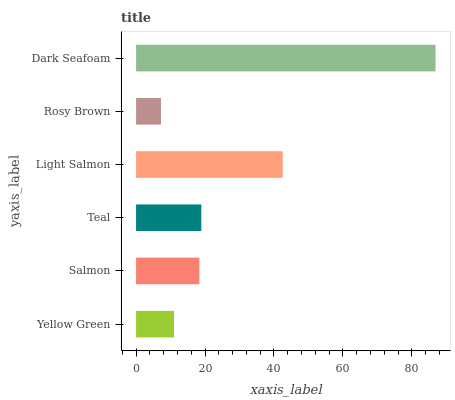Is Rosy Brown the minimum?
Answer yes or no. Yes. Is Dark Seafoam the maximum?
Answer yes or no. Yes. Is Salmon the minimum?
Answer yes or no. No. Is Salmon the maximum?
Answer yes or no. No. Is Salmon greater than Yellow Green?
Answer yes or no. Yes. Is Yellow Green less than Salmon?
Answer yes or no. Yes. Is Yellow Green greater than Salmon?
Answer yes or no. No. Is Salmon less than Yellow Green?
Answer yes or no. No. Is Teal the high median?
Answer yes or no. Yes. Is Salmon the low median?
Answer yes or no. Yes. Is Salmon the high median?
Answer yes or no. No. Is Dark Seafoam the low median?
Answer yes or no. No. 